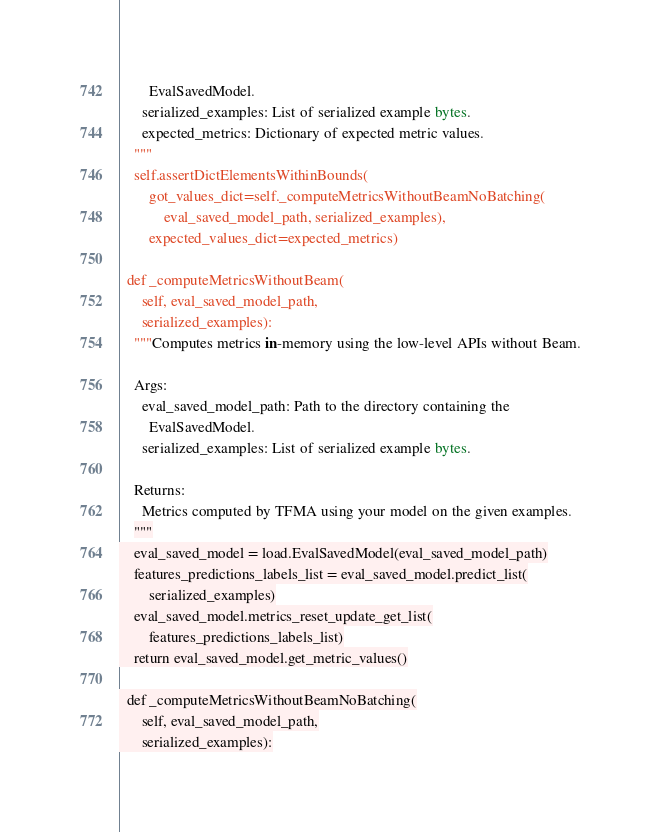Convert code to text. <code><loc_0><loc_0><loc_500><loc_500><_Python_>        EvalSavedModel.
      serialized_examples: List of serialized example bytes.
      expected_metrics: Dictionary of expected metric values.
    """
    self.assertDictElementsWithinBounds(
        got_values_dict=self._computeMetricsWithoutBeamNoBatching(
            eval_saved_model_path, serialized_examples),
        expected_values_dict=expected_metrics)

  def _computeMetricsWithoutBeam(
      self, eval_saved_model_path,
      serialized_examples):
    """Computes metrics in-memory using the low-level APIs without Beam.

    Args:
      eval_saved_model_path: Path to the directory containing the
        EvalSavedModel.
      serialized_examples: List of serialized example bytes.

    Returns:
      Metrics computed by TFMA using your model on the given examples.
    """
    eval_saved_model = load.EvalSavedModel(eval_saved_model_path)
    features_predictions_labels_list = eval_saved_model.predict_list(
        serialized_examples)
    eval_saved_model.metrics_reset_update_get_list(
        features_predictions_labels_list)
    return eval_saved_model.get_metric_values()

  def _computeMetricsWithoutBeamNoBatching(
      self, eval_saved_model_path,
      serialized_examples):</code> 